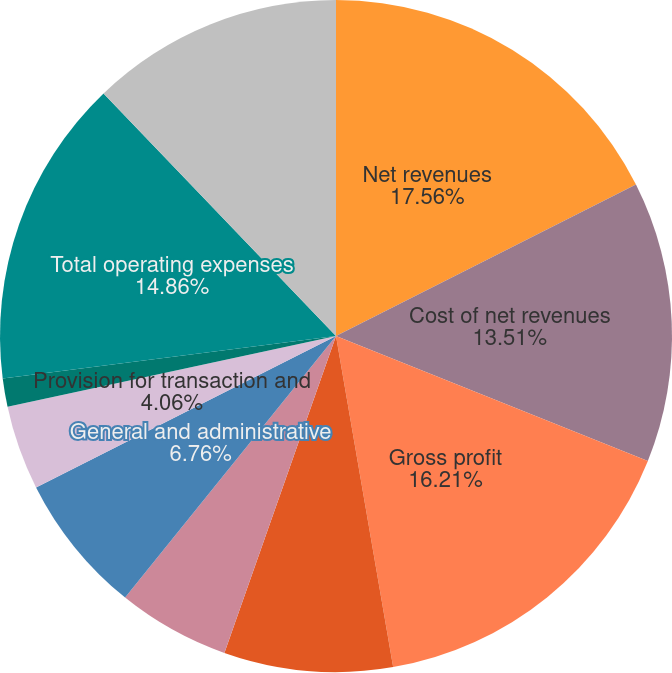<chart> <loc_0><loc_0><loc_500><loc_500><pie_chart><fcel>Net revenues<fcel>Cost of net revenues<fcel>Gross profit<fcel>Sales and marketing<fcel>Product development<fcel>General and administrative<fcel>Provision for transaction and<fcel>Amortization of acquired<fcel>Total operating expenses<fcel>Income from operations of<nl><fcel>17.56%<fcel>13.51%<fcel>16.21%<fcel>8.11%<fcel>5.41%<fcel>6.76%<fcel>4.06%<fcel>1.36%<fcel>14.86%<fcel>12.16%<nl></chart> 